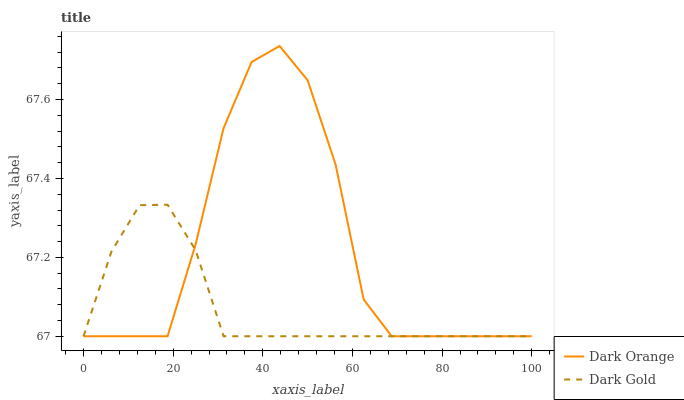Does Dark Gold have the maximum area under the curve?
Answer yes or no. No. Is Dark Gold the roughest?
Answer yes or no. No. Does Dark Gold have the highest value?
Answer yes or no. No. 